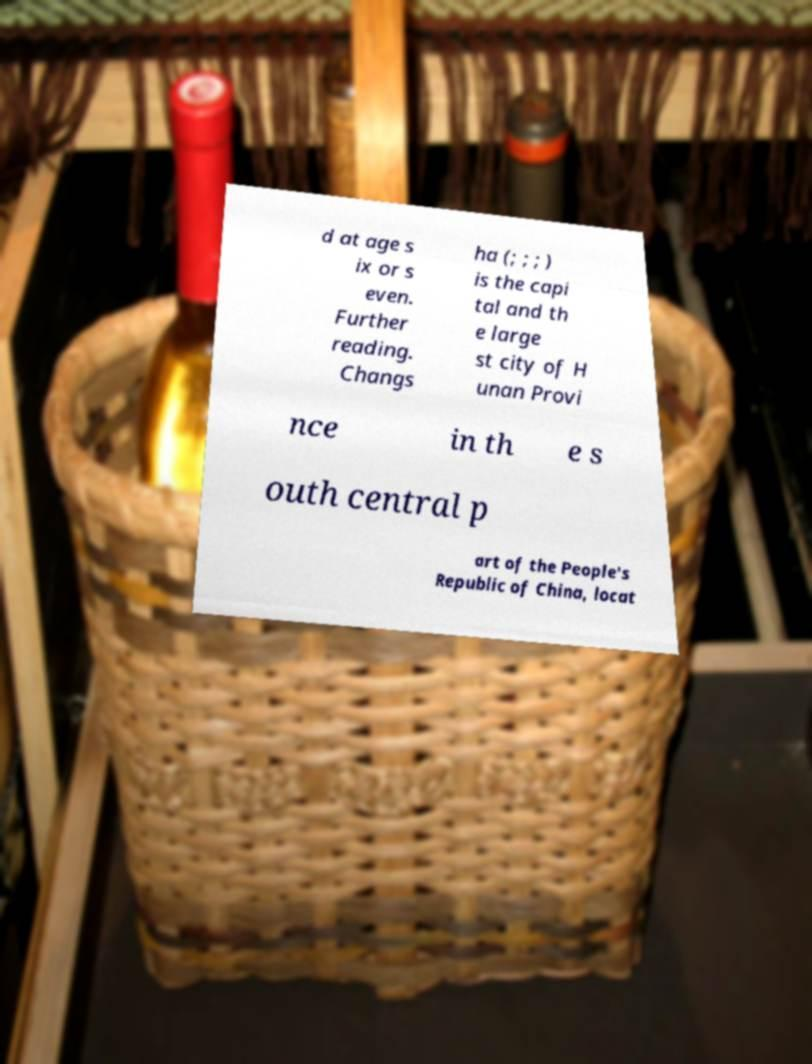For documentation purposes, I need the text within this image transcribed. Could you provide that? d at age s ix or s even. Further reading. Changs ha (; ; ; ) is the capi tal and th e large st city of H unan Provi nce in th e s outh central p art of the People's Republic of China, locat 